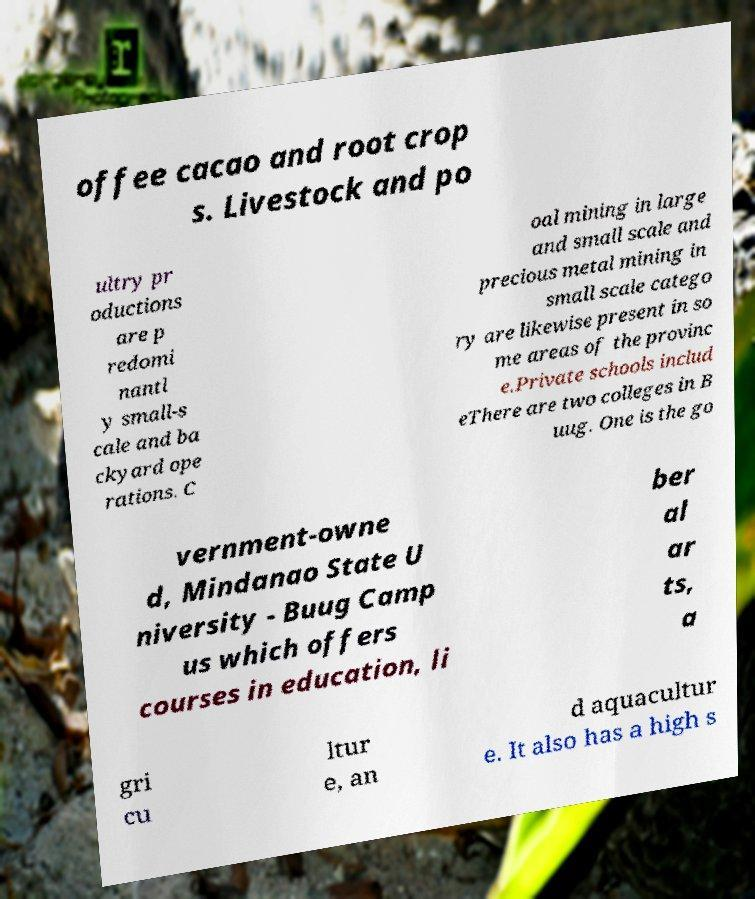Could you assist in decoding the text presented in this image and type it out clearly? offee cacao and root crop s. Livestock and po ultry pr oductions are p redomi nantl y small-s cale and ba ckyard ope rations. C oal mining in large and small scale and precious metal mining in small scale catego ry are likewise present in so me areas of the provinc e.Private schools includ eThere are two colleges in B uug. One is the go vernment-owne d, Mindanao State U niversity - Buug Camp us which offers courses in education, li ber al ar ts, a gri cu ltur e, an d aquacultur e. It also has a high s 